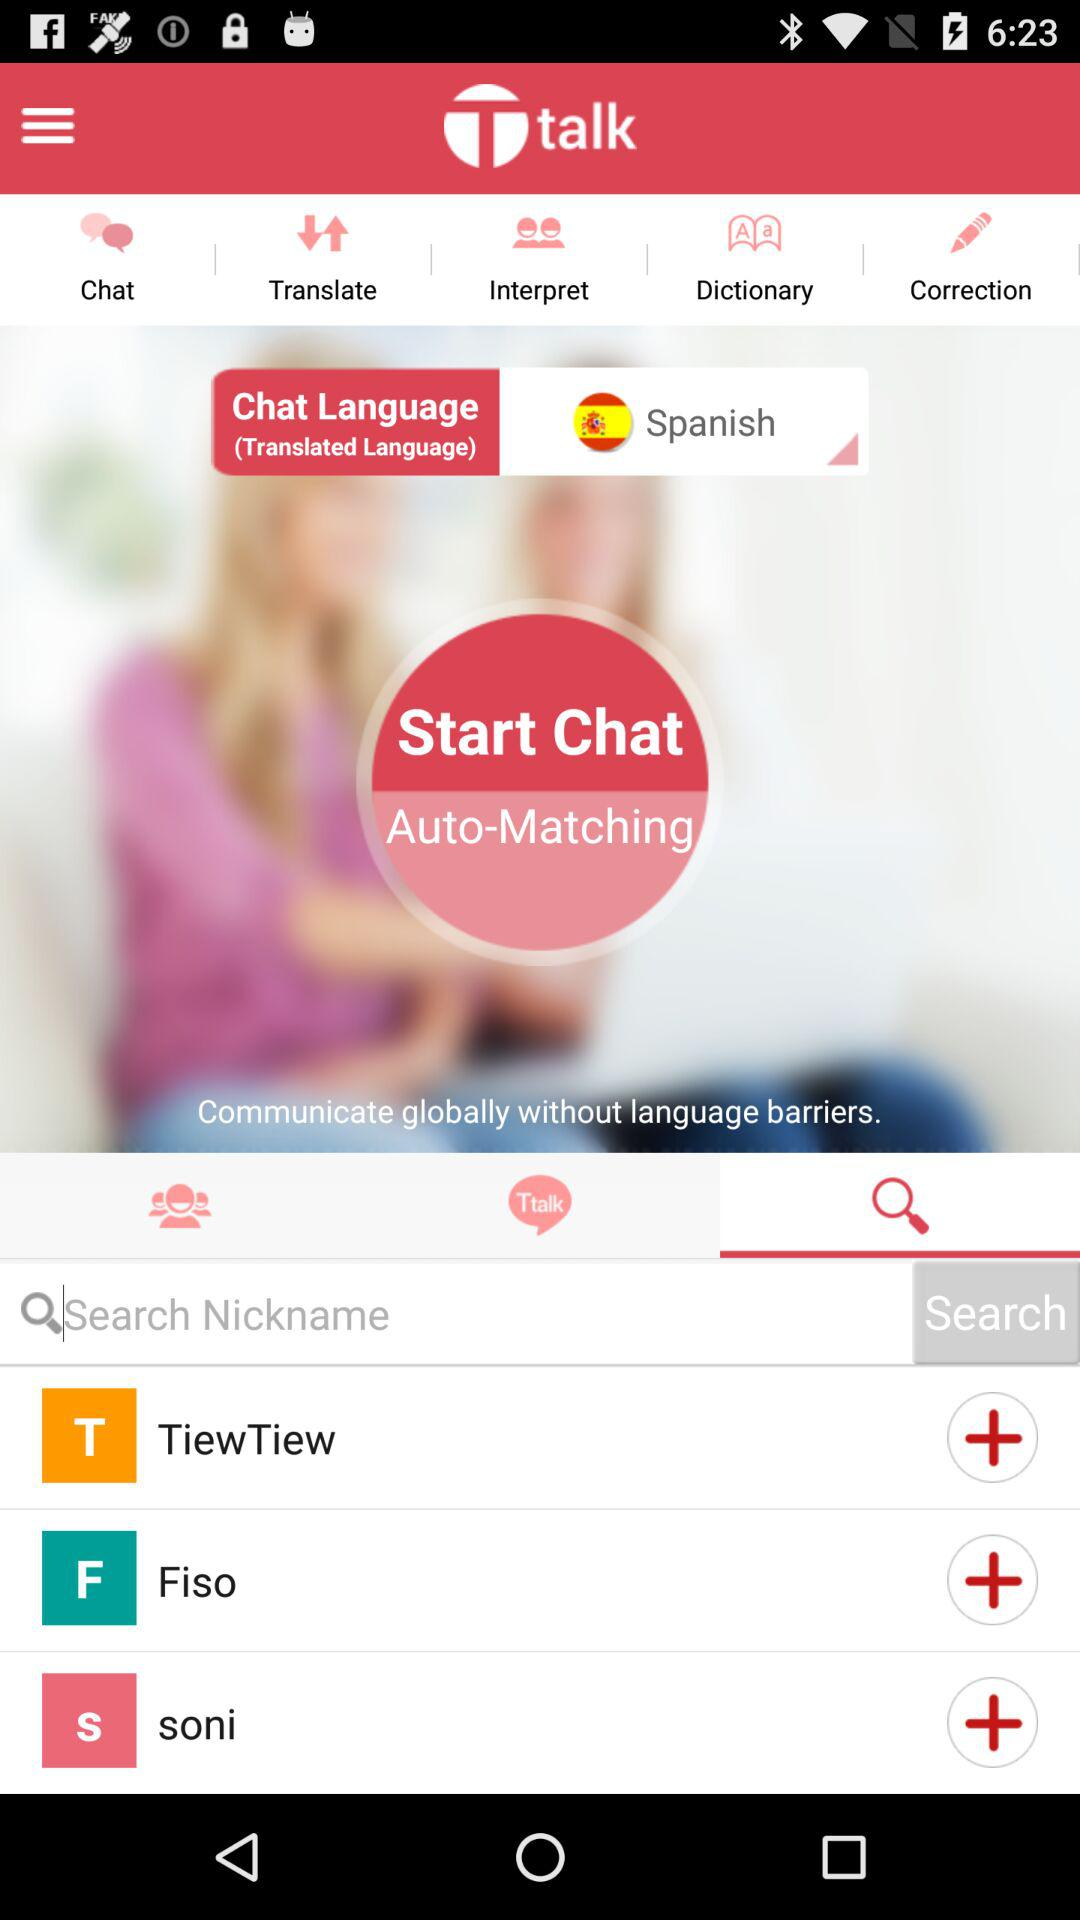What is the selected chat language? The selected chat language is Spanish. 